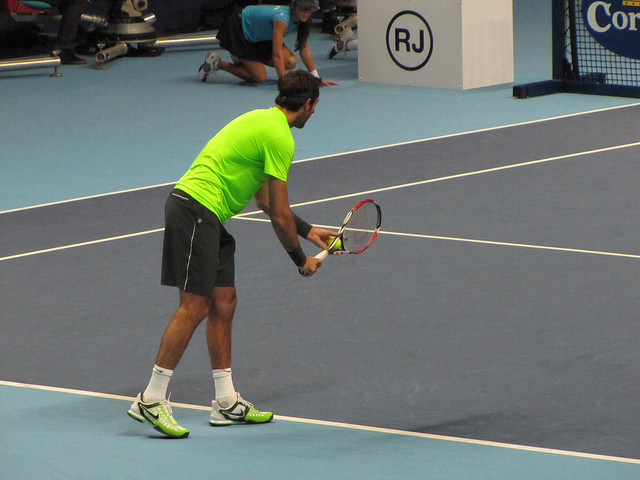<image>What brand of clothing is the man wearing? I am not sure of the brand of clothing the man is wearing. It could possibly be Nike. What brand of clothing is the man wearing? I am not sure what brand of clothing the man is wearing. It can be Nike or another brand. 